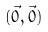Convert formula to latex. <formula><loc_0><loc_0><loc_500><loc_500>( \vec { 0 } , \vec { 0 } )</formula> 